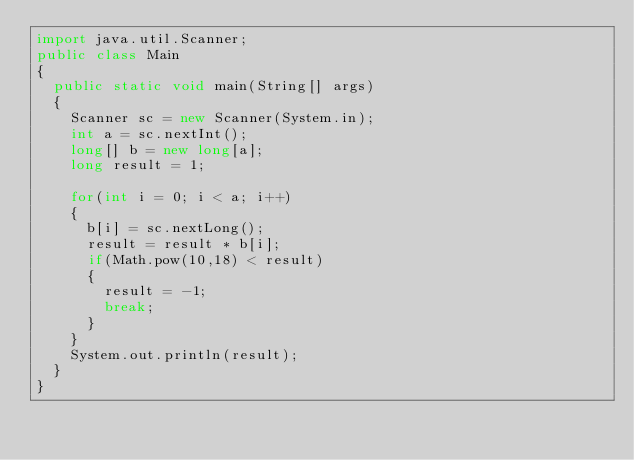<code> <loc_0><loc_0><loc_500><loc_500><_Java_>import java.util.Scanner;
public class Main
{
  public static void main(String[] args)
  {
    Scanner sc = new Scanner(System.in);
    int a = sc.nextInt();
    long[] b = new long[a];
    long result = 1;
    
    for(int i = 0; i < a; i++)
    {
      b[i] = sc.nextLong();
      result = result * b[i];
      if(Math.pow(10,18) < result)
      {
        result = -1;
        break;
      }
    }
    System.out.println(result);
  }
}
</code> 